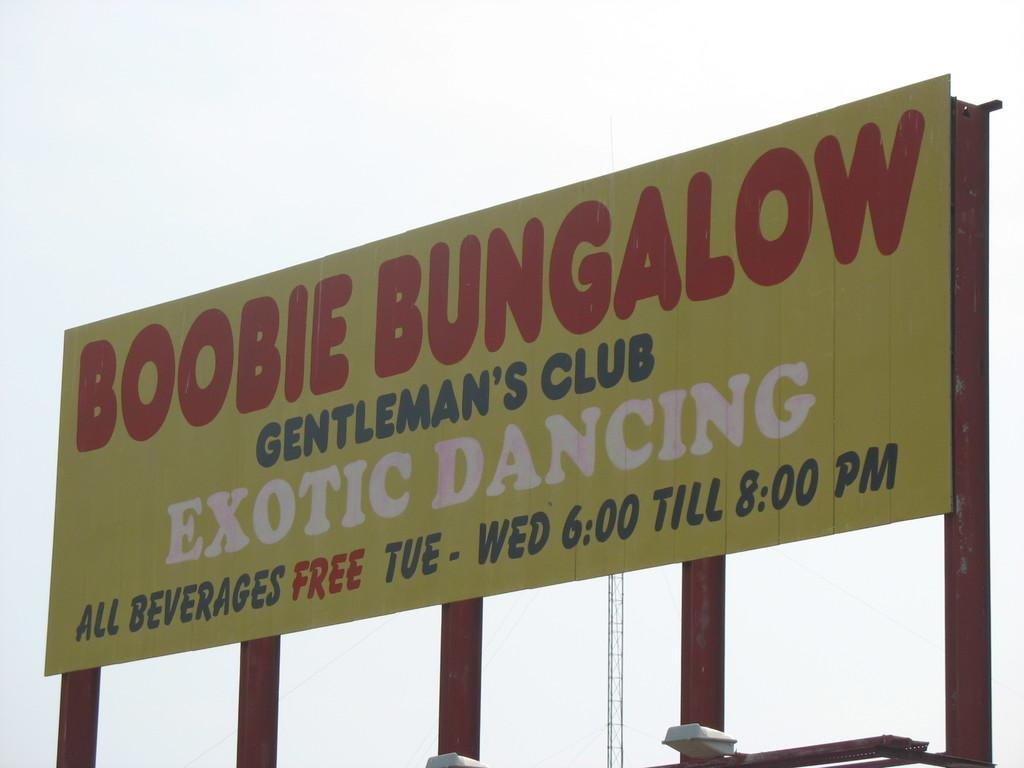Provide a one-sentence caption for the provided image. Yellow billboard with red words that say Boobie Bungalow. 